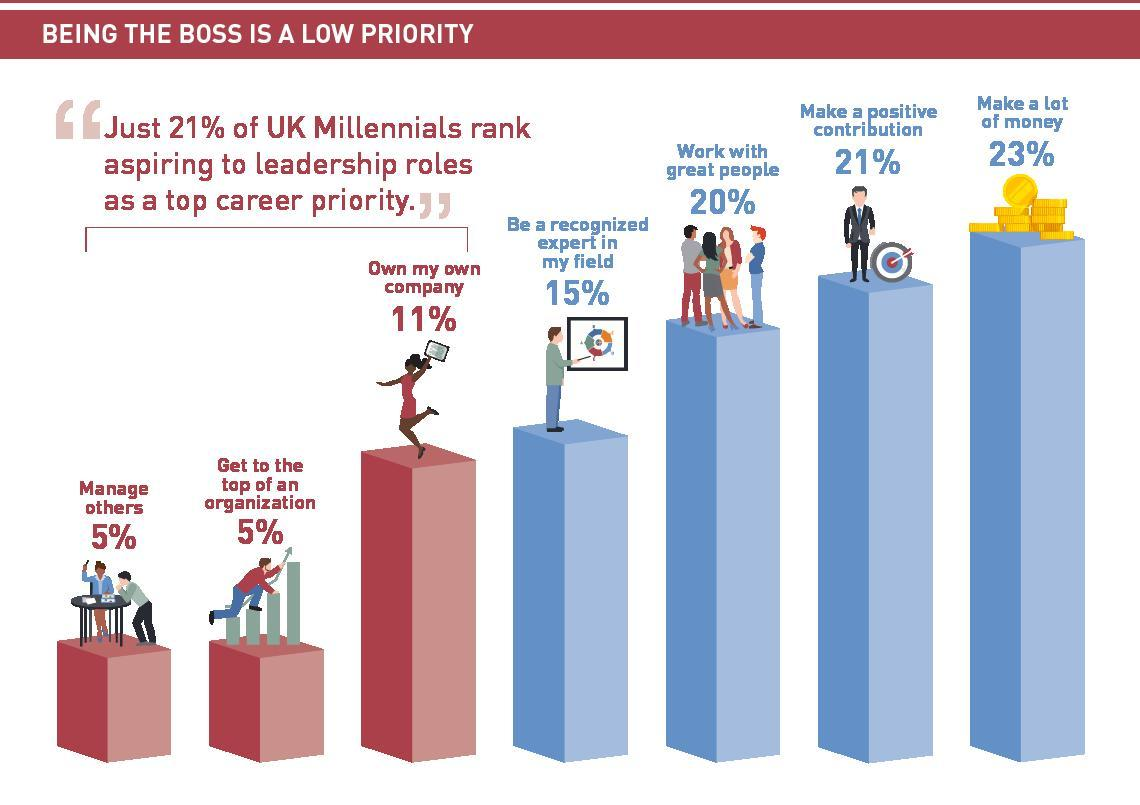What is the combined percentage of people who want to manage others or get to the top of a company?
Answer the question with a short phrase. 10% What is the combined percentage of people who want to make money or make a  positive contribution? 44% 